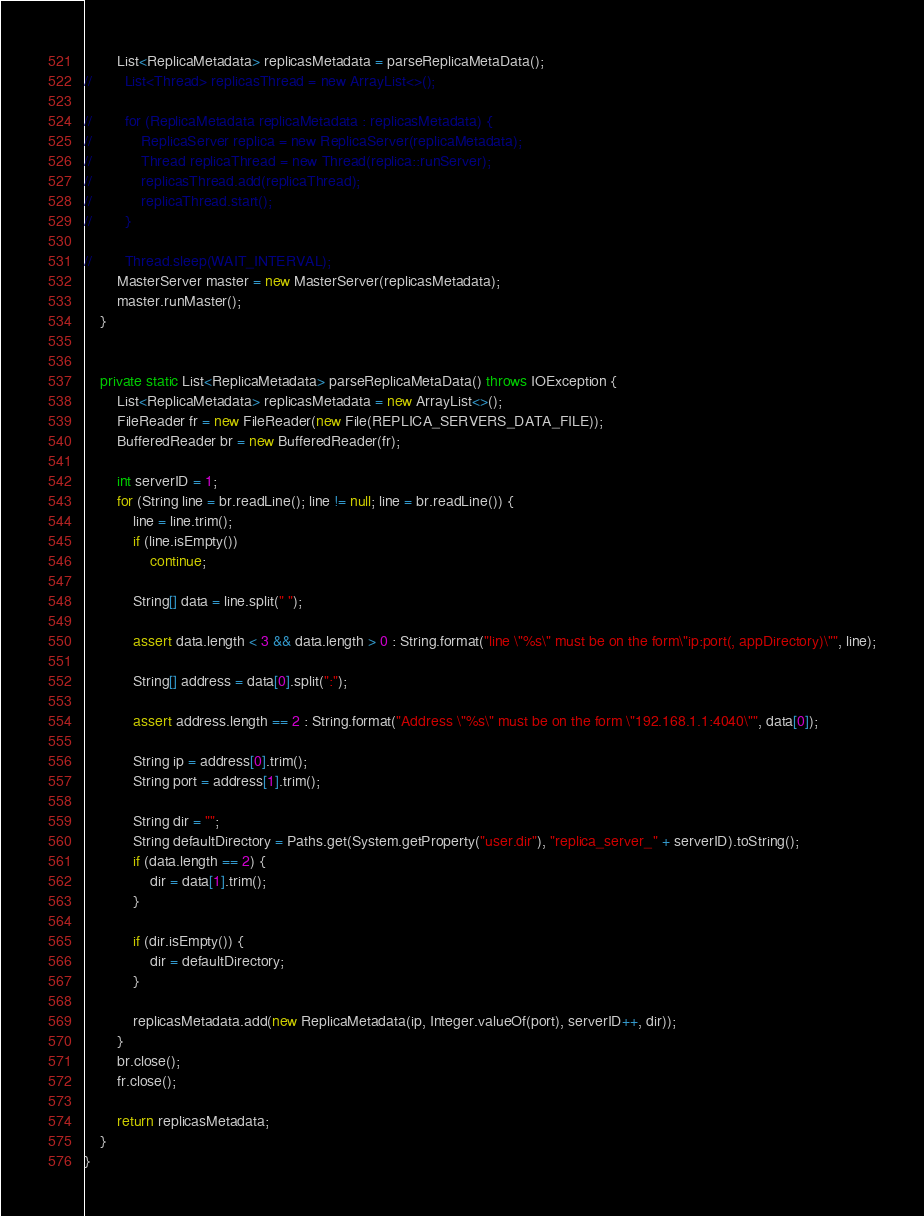<code> <loc_0><loc_0><loc_500><loc_500><_Java_>        List<ReplicaMetadata> replicasMetadata = parseReplicaMetaData();
//        List<Thread> replicasThread = new ArrayList<>();

//        for (ReplicaMetadata replicaMetadata : replicasMetadata) {
//            ReplicaServer replica = new ReplicaServer(replicaMetadata);
//            Thread replicaThread = new Thread(replica::runServer);
//            replicasThread.add(replicaThread);
//            replicaThread.start();
//        }

//        Thread.sleep(WAIT_INTERVAL);
        MasterServer master = new MasterServer(replicasMetadata);
        master.runMaster();
    }


    private static List<ReplicaMetadata> parseReplicaMetaData() throws IOException {
        List<ReplicaMetadata> replicasMetadata = new ArrayList<>();
        FileReader fr = new FileReader(new File(REPLICA_SERVERS_DATA_FILE));
        BufferedReader br = new BufferedReader(fr);

        int serverID = 1;
        for (String line = br.readLine(); line != null; line = br.readLine()) {
            line = line.trim();
            if (line.isEmpty())
                continue;

            String[] data = line.split(" ");

            assert data.length < 3 && data.length > 0 : String.format("line \"%s\" must be on the form\"ip:port(, appDirectory)\"", line);

            String[] address = data[0].split(":");

            assert address.length == 2 : String.format("Address \"%s\" must be on the form \"192.168.1.1:4040\"", data[0]);

            String ip = address[0].trim();
            String port = address[1].trim();

            String dir = "";
            String defaultDirectory = Paths.get(System.getProperty("user.dir"), "replica_server_" + serverID).toString();
            if (data.length == 2) {
                dir = data[1].trim();
            }

            if (dir.isEmpty()) {
                dir = defaultDirectory;
            }

            replicasMetadata.add(new ReplicaMetadata(ip, Integer.valueOf(port), serverID++, dir));
        }
        br.close();
        fr.close();

        return replicasMetadata;
    }
}</code> 